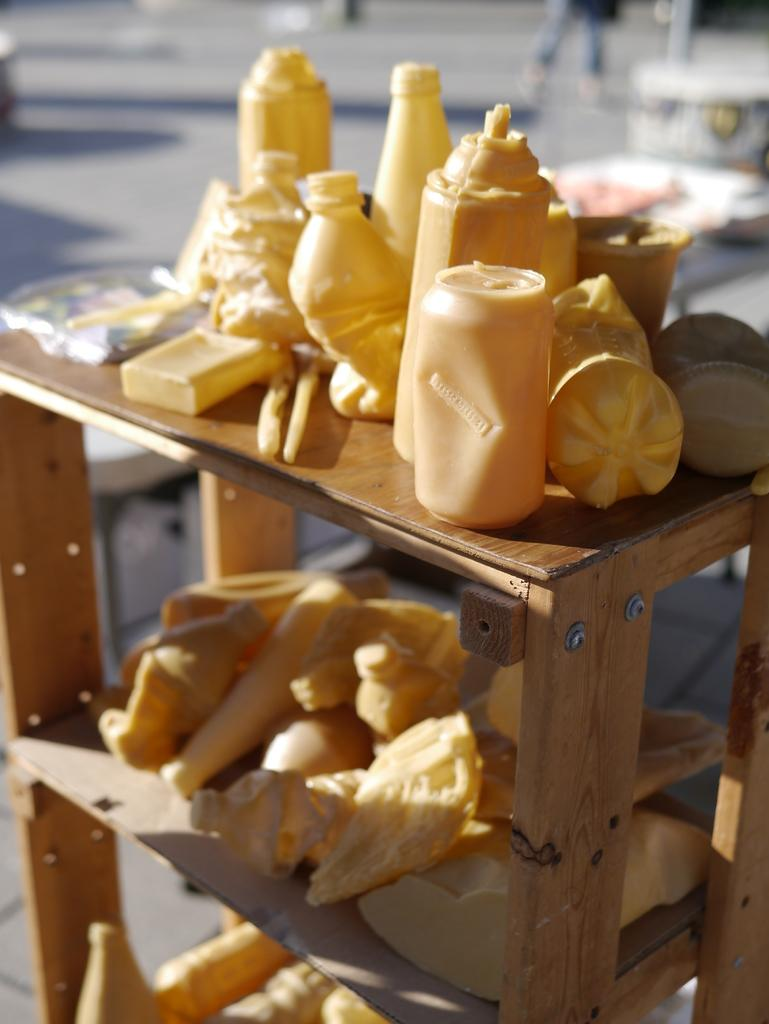What type of objects can be seen in the image? There are bottles and a can in the image. What material are the objects made of? The objects are made of plastic. Where are the objects placed in the image? The objects are placed on a wooden rack. How would you describe the background of the image? The background of the image appears blurry. What type of wrench is being used to tighten the iron pan in the image? There is no wrench or iron pan present in the image. 